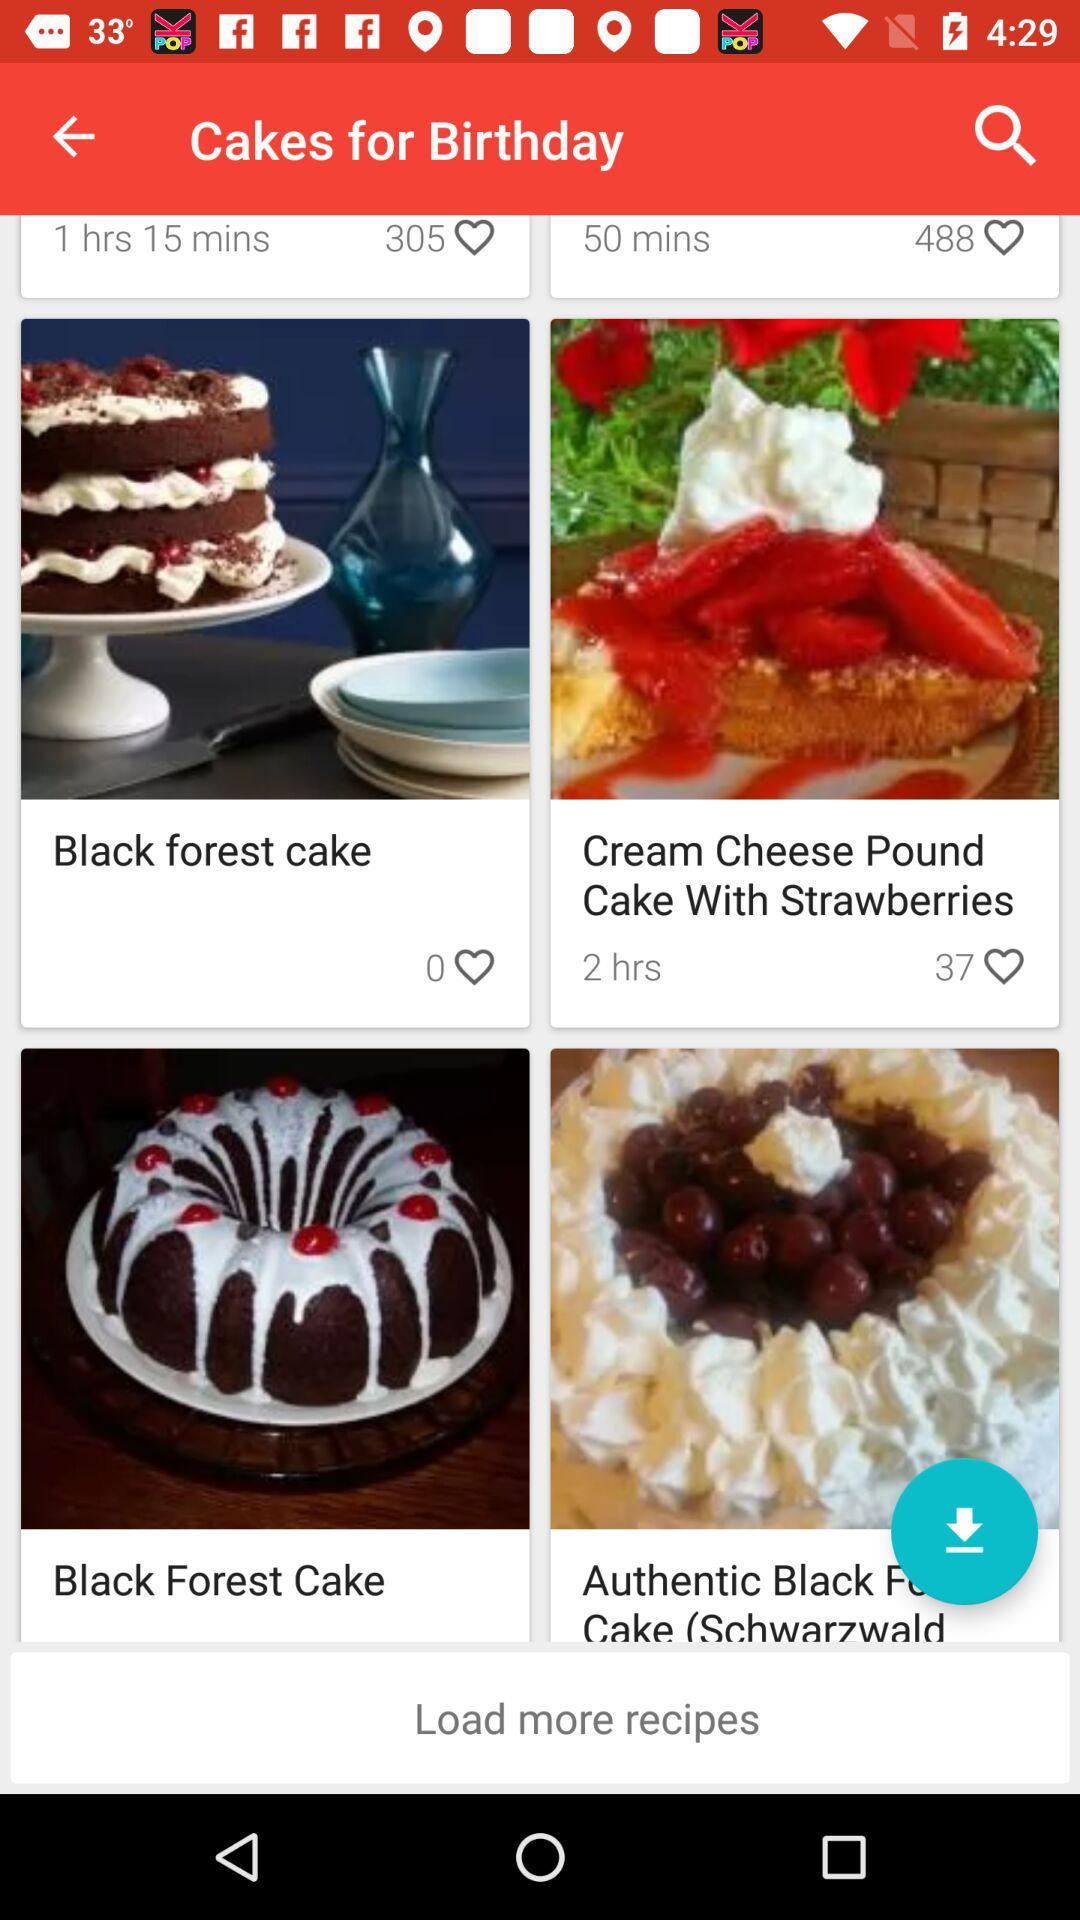How many likes are on "Black forest cake"? There are 0 likes. 